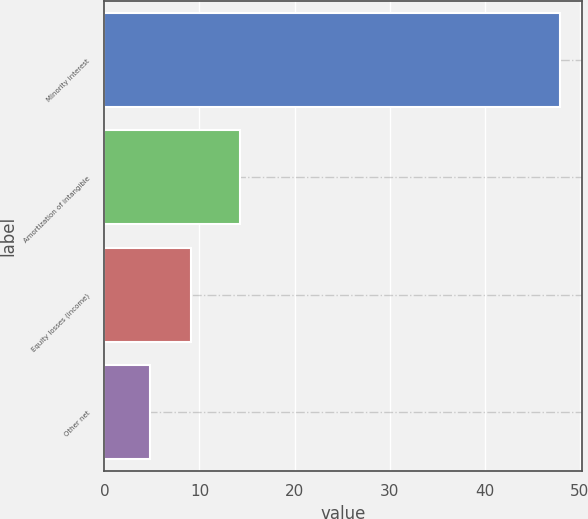<chart> <loc_0><loc_0><loc_500><loc_500><bar_chart><fcel>Minority interest<fcel>Amortization of intangible<fcel>Equity losses (income)<fcel>Other net<nl><fcel>47.9<fcel>14.3<fcel>9.11<fcel>4.8<nl></chart> 